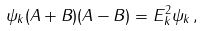Convert formula to latex. <formula><loc_0><loc_0><loc_500><loc_500>\psi _ { k } ( { A } + { B } ) ( { A } - { B } ) = E ^ { 2 } _ { k } \psi _ { k } \, ,</formula> 